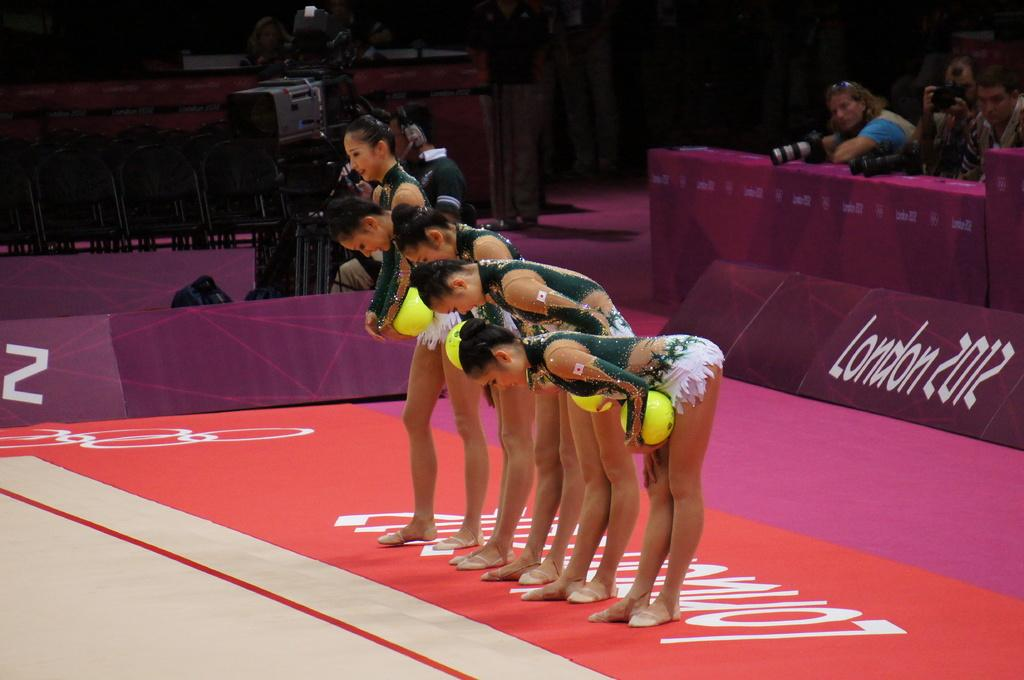<image>
Offer a succinct explanation of the picture presented. Five Asian female sports players are bowing in a line up, with London 2012 written on the flooring and in back of them. 